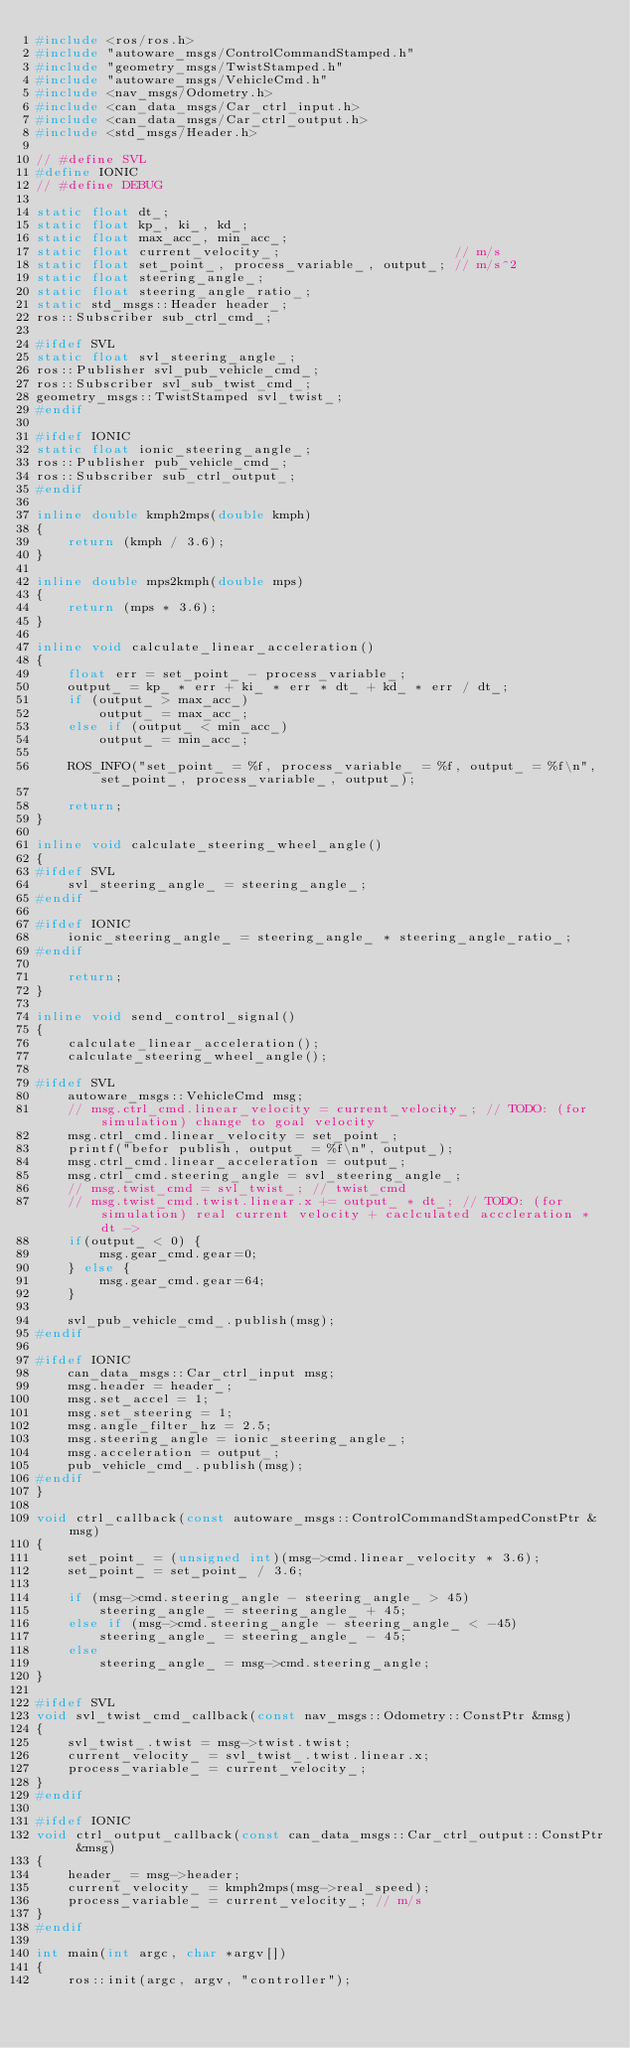<code> <loc_0><loc_0><loc_500><loc_500><_C++_>#include <ros/ros.h>
#include "autoware_msgs/ControlCommandStamped.h"
#include "geometry_msgs/TwistStamped.h"
#include "autoware_msgs/VehicleCmd.h"
#include <nav_msgs/Odometry.h>
#include <can_data_msgs/Car_ctrl_input.h>
#include <can_data_msgs/Car_ctrl_output.h>
#include <std_msgs/Header.h>

// #define SVL
#define IONIC
// #define DEBUG

static float dt_;
static float kp_, ki_, kd_;
static float max_acc_, min_acc_;
static float current_velocity_;                      // m/s
static float set_point_, process_variable_, output_; // m/s^2
static float steering_angle_;
static float steering_angle_ratio_;
static std_msgs::Header header_;
ros::Subscriber sub_ctrl_cmd_;

#ifdef SVL
static float svl_steering_angle_;
ros::Publisher svl_pub_vehicle_cmd_;
ros::Subscriber svl_sub_twist_cmd_;
geometry_msgs::TwistStamped svl_twist_;
#endif

#ifdef IONIC
static float ionic_steering_angle_;
ros::Publisher pub_vehicle_cmd_;
ros::Subscriber sub_ctrl_output_;
#endif

inline double kmph2mps(double kmph)
{
    return (kmph / 3.6);
}

inline double mps2kmph(double mps)
{
    return (mps * 3.6);
}

inline void calculate_linear_acceleration()
{
    float err = set_point_ - process_variable_;
    output_ = kp_ * err + ki_ * err * dt_ + kd_ * err / dt_;
    if (output_ > max_acc_)
        output_ = max_acc_;
    else if (output_ < min_acc_)
        output_ = min_acc_;

    ROS_INFO("set_point_ = %f, process_variable_ = %f, output_ = %f\n", set_point_, process_variable_, output_);

    return;
}

inline void calculate_steering_wheel_angle()
{
#ifdef SVL
    svl_steering_angle_ = steering_angle_;
#endif

#ifdef IONIC
    ionic_steering_angle_ = steering_angle_ * steering_angle_ratio_;
#endif

    return;
}

inline void send_control_signal()
{
    calculate_linear_acceleration();
    calculate_steering_wheel_angle();

#ifdef SVL
    autoware_msgs::VehicleCmd msg;
    // msg.ctrl_cmd.linear_velocity = current_velocity_; // TODO: (for simulation) change to goal velocity
    msg.ctrl_cmd.linear_velocity = set_point_;
    printf("befor publish, output_ = %f\n", output_);
    msg.ctrl_cmd.linear_acceleration = output_;
    msg.ctrl_cmd.steering_angle = svl_steering_angle_;
    // msg.twist_cmd = svl_twist_; // twist_cmd
    // msg.twist_cmd.twist.linear.x += output_ * dt_; // TODO: (for simulation) real current velocity + caclculated acccleration * dt -> 
    if(output_ < 0) {
        msg.gear_cmd.gear=0;
    } else {
        msg.gear_cmd.gear=64;
    }

    svl_pub_vehicle_cmd_.publish(msg);
#endif

#ifdef IONIC
    can_data_msgs::Car_ctrl_input msg;
    msg.header = header_;
    msg.set_accel = 1;
    msg.set_steering = 1;
    msg.angle_filter_hz = 2.5;
    msg.steering_angle = ionic_steering_angle_;
    msg.acceleration = output_;
    pub_vehicle_cmd_.publish(msg);
#endif
}

void ctrl_callback(const autoware_msgs::ControlCommandStampedConstPtr &msg)
{
    set_point_ = (unsigned int)(msg->cmd.linear_velocity * 3.6);
    set_point_ = set_point_ / 3.6;

    if (msg->cmd.steering_angle - steering_angle_ > 45)
        steering_angle_ = steering_angle_ + 45;
    else if (msg->cmd.steering_angle - steering_angle_ < -45)
        steering_angle_ = steering_angle_ - 45;
    else
        steering_angle_ = msg->cmd.steering_angle;
}

#ifdef SVL
void svl_twist_cmd_callback(const nav_msgs::Odometry::ConstPtr &msg)
{
    svl_twist_.twist = msg->twist.twist;
    current_velocity_ = svl_twist_.twist.linear.x;
    process_variable_ = current_velocity_;
}
#endif

#ifdef IONIC
void ctrl_output_callback(const can_data_msgs::Car_ctrl_output::ConstPtr &msg)
{
    header_ = msg->header;
    current_velocity_ = kmph2mps(msg->real_speed);
    process_variable_ = current_velocity_; // m/s
}
#endif

int main(int argc, char *argv[])
{
    ros::init(argc, argv, "controller");</code> 